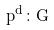Convert formula to latex. <formula><loc_0><loc_0><loc_500><loc_500>p ^ { d } \colon G</formula> 